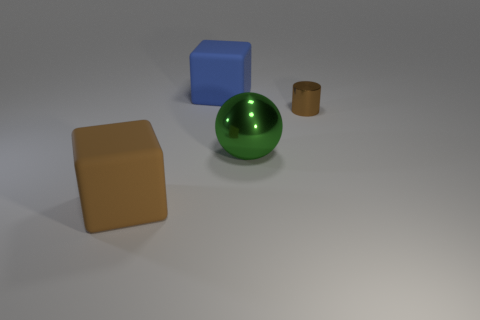Are there any things to the right of the large object on the right side of the big block that is behind the large green metallic sphere?
Offer a terse response. Yes. What number of metal cylinders have the same size as the sphere?
Ensure brevity in your answer.  0. What is the material of the brown thing that is on the right side of the big matte thing in front of the large green metallic ball?
Make the answer very short. Metal. There is a rubber thing that is to the right of the thing that is on the left side of the big cube that is behind the tiny cylinder; what is its shape?
Keep it short and to the point. Cube. There is a big matte thing that is behind the shiny cylinder; is its shape the same as the thing to the right of the ball?
Provide a succinct answer. No. What shape is the brown object that is made of the same material as the big blue thing?
Provide a short and direct response. Cube. Do the green metallic ball and the brown matte thing have the same size?
Ensure brevity in your answer.  Yes. How big is the matte block in front of the metal thing behind the green metallic sphere?
Offer a terse response. Large. The other object that is the same color as the small object is what shape?
Your response must be concise. Cube. How many blocks are either rubber objects or blue rubber things?
Your response must be concise. 2. 